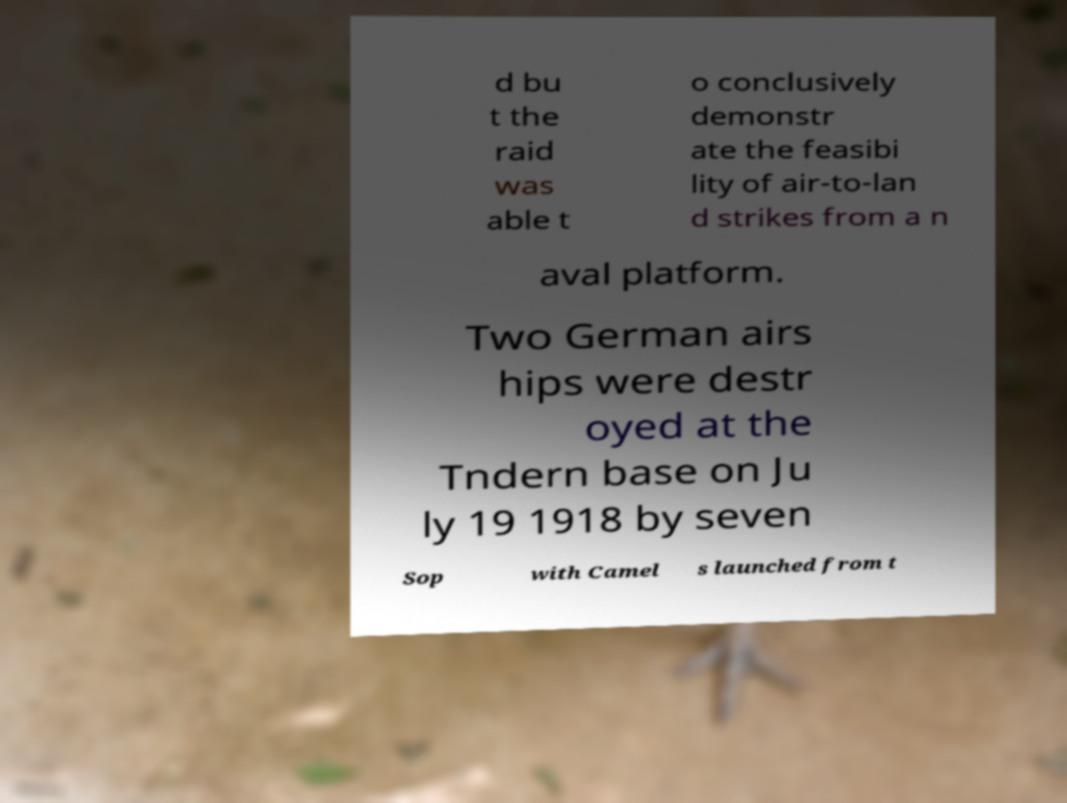Can you read and provide the text displayed in the image?This photo seems to have some interesting text. Can you extract and type it out for me? d bu t the raid was able t o conclusively demonstr ate the feasibi lity of air-to-lan d strikes from a n aval platform. Two German airs hips were destr oyed at the Tndern base on Ju ly 19 1918 by seven Sop with Camel s launched from t 